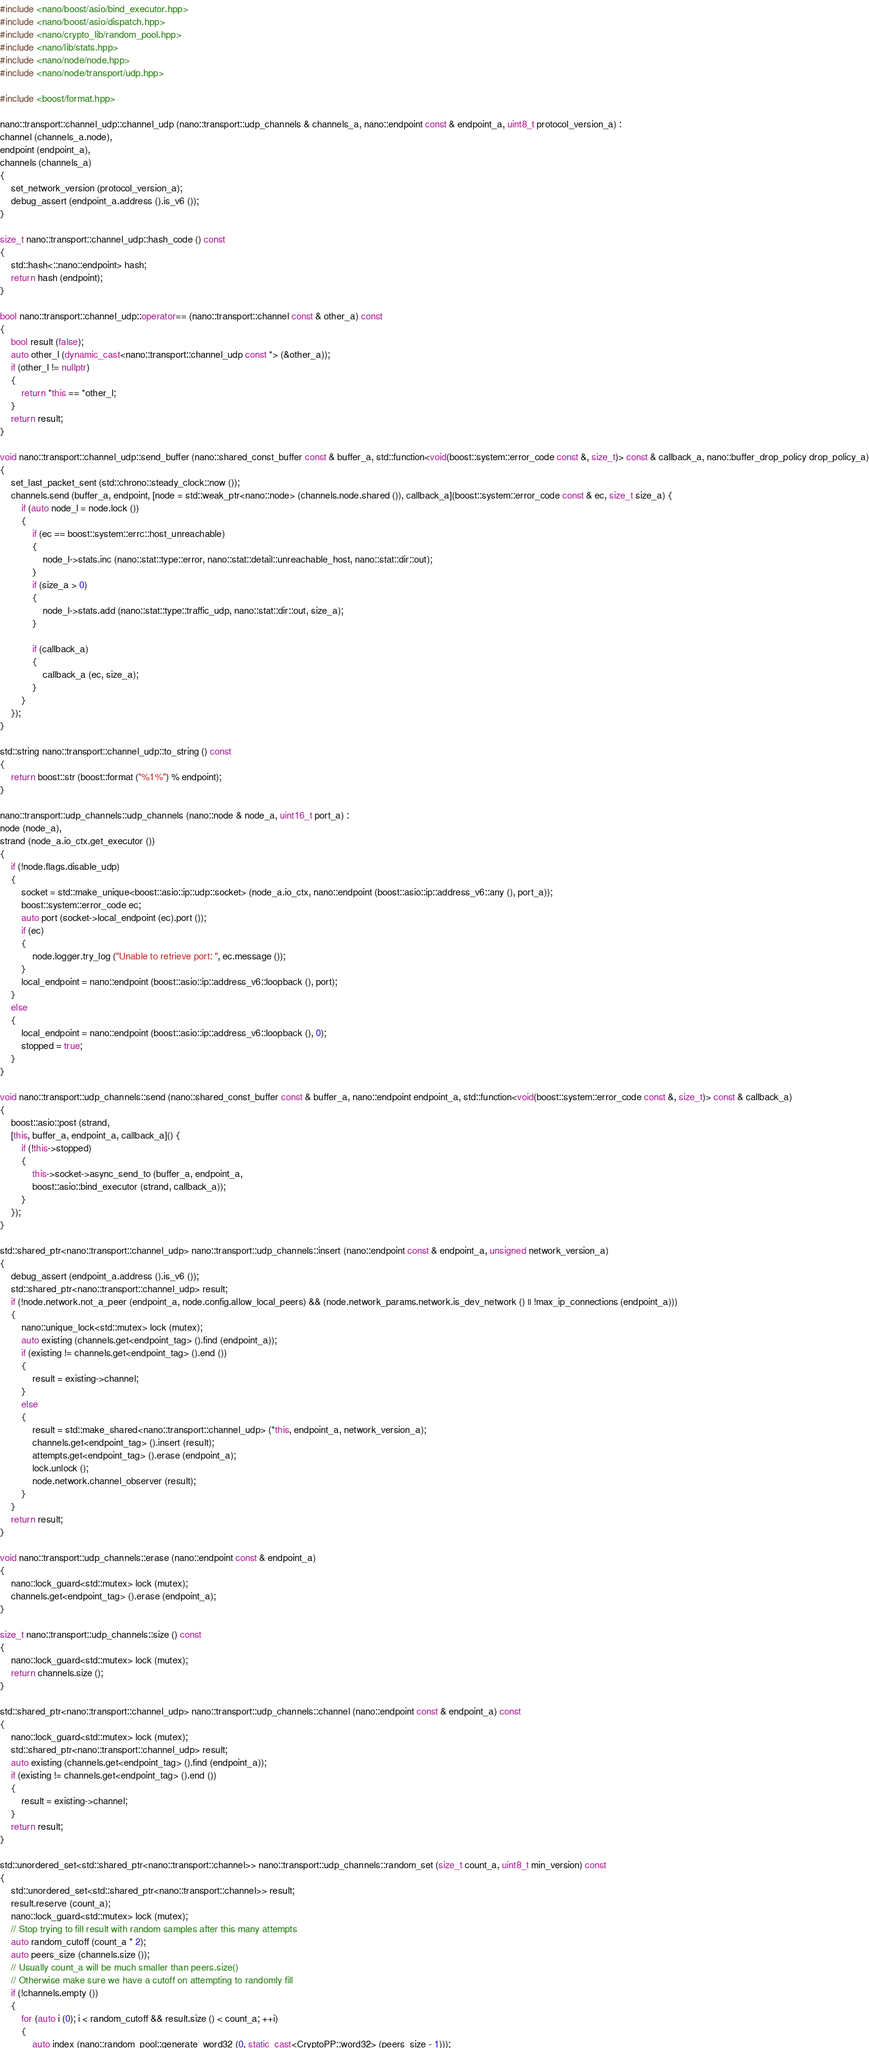Convert code to text. <code><loc_0><loc_0><loc_500><loc_500><_C++_>#include <nano/boost/asio/bind_executor.hpp>
#include <nano/boost/asio/dispatch.hpp>
#include <nano/crypto_lib/random_pool.hpp>
#include <nano/lib/stats.hpp>
#include <nano/node/node.hpp>
#include <nano/node/transport/udp.hpp>

#include <boost/format.hpp>

nano::transport::channel_udp::channel_udp (nano::transport::udp_channels & channels_a, nano::endpoint const & endpoint_a, uint8_t protocol_version_a) :
channel (channels_a.node),
endpoint (endpoint_a),
channels (channels_a)
{
	set_network_version (protocol_version_a);
	debug_assert (endpoint_a.address ().is_v6 ());
}

size_t nano::transport::channel_udp::hash_code () const
{
	std::hash<::nano::endpoint> hash;
	return hash (endpoint);
}

bool nano::transport::channel_udp::operator== (nano::transport::channel const & other_a) const
{
	bool result (false);
	auto other_l (dynamic_cast<nano::transport::channel_udp const *> (&other_a));
	if (other_l != nullptr)
	{
		return *this == *other_l;
	}
	return result;
}

void nano::transport::channel_udp::send_buffer (nano::shared_const_buffer const & buffer_a, std::function<void(boost::system::error_code const &, size_t)> const & callback_a, nano::buffer_drop_policy drop_policy_a)
{
	set_last_packet_sent (std::chrono::steady_clock::now ());
	channels.send (buffer_a, endpoint, [node = std::weak_ptr<nano::node> (channels.node.shared ()), callback_a](boost::system::error_code const & ec, size_t size_a) {
		if (auto node_l = node.lock ())
		{
			if (ec == boost::system::errc::host_unreachable)
			{
				node_l->stats.inc (nano::stat::type::error, nano::stat::detail::unreachable_host, nano::stat::dir::out);
			}
			if (size_a > 0)
			{
				node_l->stats.add (nano::stat::type::traffic_udp, nano::stat::dir::out, size_a);
			}

			if (callback_a)
			{
				callback_a (ec, size_a);
			}
		}
	});
}

std::string nano::transport::channel_udp::to_string () const
{
	return boost::str (boost::format ("%1%") % endpoint);
}

nano::transport::udp_channels::udp_channels (nano::node & node_a, uint16_t port_a) :
node (node_a),
strand (node_a.io_ctx.get_executor ())
{
	if (!node.flags.disable_udp)
	{
		socket = std::make_unique<boost::asio::ip::udp::socket> (node_a.io_ctx, nano::endpoint (boost::asio::ip::address_v6::any (), port_a));
		boost::system::error_code ec;
		auto port (socket->local_endpoint (ec).port ());
		if (ec)
		{
			node.logger.try_log ("Unable to retrieve port: ", ec.message ());
		}
		local_endpoint = nano::endpoint (boost::asio::ip::address_v6::loopback (), port);
	}
	else
	{
		local_endpoint = nano::endpoint (boost::asio::ip::address_v6::loopback (), 0);
		stopped = true;
	}
}

void nano::transport::udp_channels::send (nano::shared_const_buffer const & buffer_a, nano::endpoint endpoint_a, std::function<void(boost::system::error_code const &, size_t)> const & callback_a)
{
	boost::asio::post (strand,
	[this, buffer_a, endpoint_a, callback_a]() {
		if (!this->stopped)
		{
			this->socket->async_send_to (buffer_a, endpoint_a,
			boost::asio::bind_executor (strand, callback_a));
		}
	});
}

std::shared_ptr<nano::transport::channel_udp> nano::transport::udp_channels::insert (nano::endpoint const & endpoint_a, unsigned network_version_a)
{
	debug_assert (endpoint_a.address ().is_v6 ());
	std::shared_ptr<nano::transport::channel_udp> result;
	if (!node.network.not_a_peer (endpoint_a, node.config.allow_local_peers) && (node.network_params.network.is_dev_network () || !max_ip_connections (endpoint_a)))
	{
		nano::unique_lock<std::mutex> lock (mutex);
		auto existing (channels.get<endpoint_tag> ().find (endpoint_a));
		if (existing != channels.get<endpoint_tag> ().end ())
		{
			result = existing->channel;
		}
		else
		{
			result = std::make_shared<nano::transport::channel_udp> (*this, endpoint_a, network_version_a);
			channels.get<endpoint_tag> ().insert (result);
			attempts.get<endpoint_tag> ().erase (endpoint_a);
			lock.unlock ();
			node.network.channel_observer (result);
		}
	}
	return result;
}

void nano::transport::udp_channels::erase (nano::endpoint const & endpoint_a)
{
	nano::lock_guard<std::mutex> lock (mutex);
	channels.get<endpoint_tag> ().erase (endpoint_a);
}

size_t nano::transport::udp_channels::size () const
{
	nano::lock_guard<std::mutex> lock (mutex);
	return channels.size ();
}

std::shared_ptr<nano::transport::channel_udp> nano::transport::udp_channels::channel (nano::endpoint const & endpoint_a) const
{
	nano::lock_guard<std::mutex> lock (mutex);
	std::shared_ptr<nano::transport::channel_udp> result;
	auto existing (channels.get<endpoint_tag> ().find (endpoint_a));
	if (existing != channels.get<endpoint_tag> ().end ())
	{
		result = existing->channel;
	}
	return result;
}

std::unordered_set<std::shared_ptr<nano::transport::channel>> nano::transport::udp_channels::random_set (size_t count_a, uint8_t min_version) const
{
	std::unordered_set<std::shared_ptr<nano::transport::channel>> result;
	result.reserve (count_a);
	nano::lock_guard<std::mutex> lock (mutex);
	// Stop trying to fill result with random samples after this many attempts
	auto random_cutoff (count_a * 2);
	auto peers_size (channels.size ());
	// Usually count_a will be much smaller than peers.size()
	// Otherwise make sure we have a cutoff on attempting to randomly fill
	if (!channels.empty ())
	{
		for (auto i (0); i < random_cutoff && result.size () < count_a; ++i)
		{
			auto index (nano::random_pool::generate_word32 (0, static_cast<CryptoPP::word32> (peers_size - 1)));</code> 